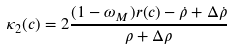<formula> <loc_0><loc_0><loc_500><loc_500>\kappa _ { 2 } ( c ) = 2 \frac { ( 1 - \omega _ { M } ) r ( c ) - \dot { \rho } + \Delta \dot { \rho } } { \rho + \Delta \rho }</formula> 